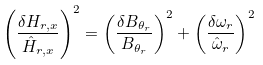<formula> <loc_0><loc_0><loc_500><loc_500>\left ( \frac { \delta H _ { r , x } } { \hat { H } _ { r , x } } \right ) ^ { 2 } = \left ( \frac { \delta B _ { \theta _ { r } } } { B _ { \theta _ { r } } } \right ) ^ { 2 } + \left ( \frac { \delta \omega _ { r } } { \hat { \omega } _ { r } } \right ) ^ { 2 }</formula> 